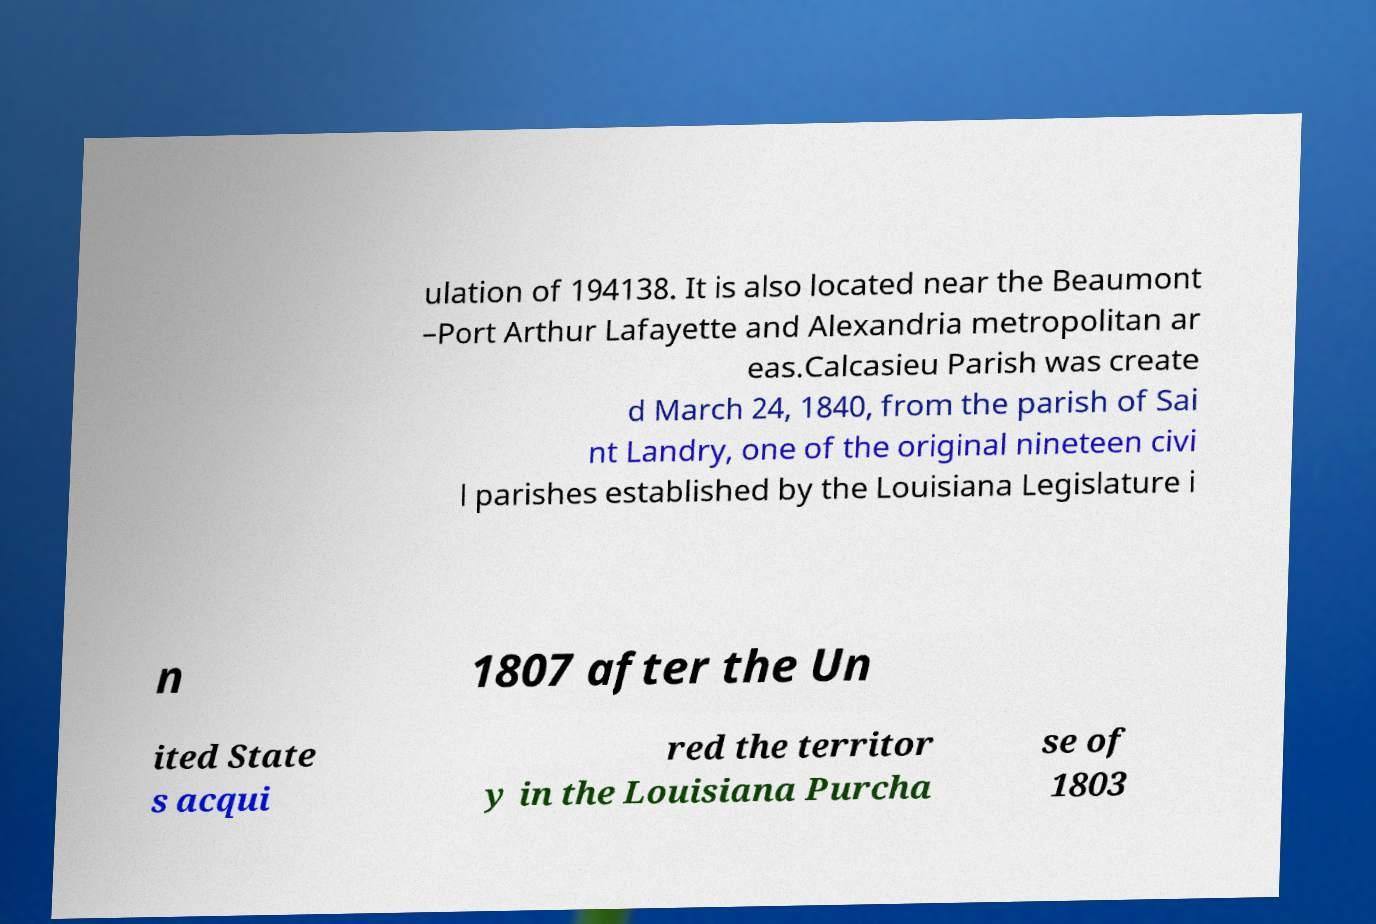There's text embedded in this image that I need extracted. Can you transcribe it verbatim? ulation of 194138. It is also located near the Beaumont –Port Arthur Lafayette and Alexandria metropolitan ar eas.Calcasieu Parish was create d March 24, 1840, from the parish of Sai nt Landry, one of the original nineteen civi l parishes established by the Louisiana Legislature i n 1807 after the Un ited State s acqui red the territor y in the Louisiana Purcha se of 1803 